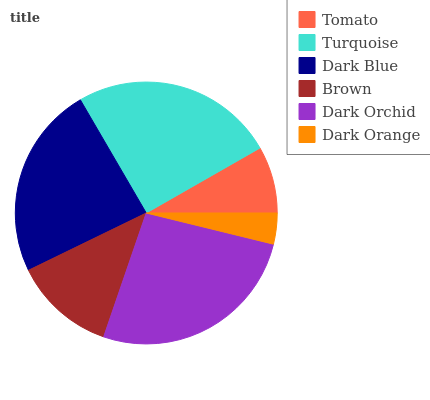Is Dark Orange the minimum?
Answer yes or no. Yes. Is Dark Orchid the maximum?
Answer yes or no. Yes. Is Turquoise the minimum?
Answer yes or no. No. Is Turquoise the maximum?
Answer yes or no. No. Is Turquoise greater than Tomato?
Answer yes or no. Yes. Is Tomato less than Turquoise?
Answer yes or no. Yes. Is Tomato greater than Turquoise?
Answer yes or no. No. Is Turquoise less than Tomato?
Answer yes or no. No. Is Dark Blue the high median?
Answer yes or no. Yes. Is Brown the low median?
Answer yes or no. Yes. Is Tomato the high median?
Answer yes or no. No. Is Dark Blue the low median?
Answer yes or no. No. 